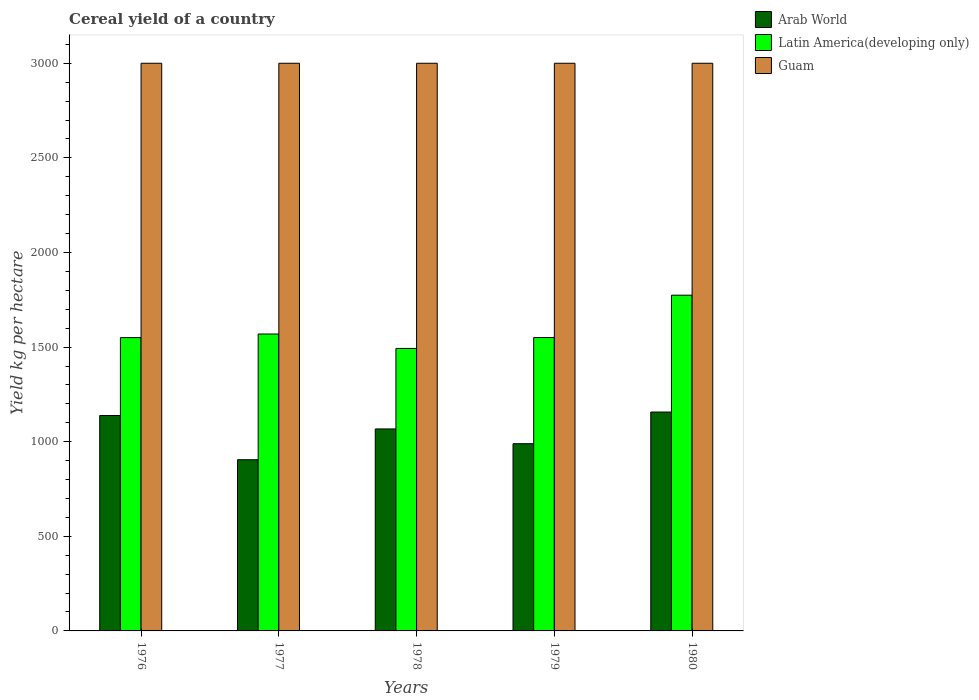How many groups of bars are there?
Your response must be concise. 5. Are the number of bars per tick equal to the number of legend labels?
Your answer should be very brief. Yes. Are the number of bars on each tick of the X-axis equal?
Your answer should be very brief. Yes. How many bars are there on the 4th tick from the left?
Offer a very short reply. 3. What is the label of the 1st group of bars from the left?
Keep it short and to the point. 1976. In how many cases, is the number of bars for a given year not equal to the number of legend labels?
Your answer should be compact. 0. What is the total cereal yield in Latin America(developing only) in 1980?
Provide a short and direct response. 1774.33. Across all years, what is the maximum total cereal yield in Guam?
Your answer should be very brief. 3000. Across all years, what is the minimum total cereal yield in Guam?
Provide a succinct answer. 3000. In which year was the total cereal yield in Guam maximum?
Make the answer very short. 1976. In which year was the total cereal yield in Guam minimum?
Make the answer very short. 1976. What is the total total cereal yield in Arab World in the graph?
Give a very brief answer. 5256.63. What is the difference between the total cereal yield in Latin America(developing only) in 1976 and that in 1978?
Your response must be concise. 57.32. What is the difference between the total cereal yield in Arab World in 1976 and the total cereal yield in Latin America(developing only) in 1979?
Offer a terse response. -412.12. What is the average total cereal yield in Arab World per year?
Your answer should be very brief. 1051.33. In the year 1980, what is the difference between the total cereal yield in Arab World and total cereal yield in Latin America(developing only)?
Offer a very short reply. -617.6. What is the ratio of the total cereal yield in Latin America(developing only) in 1977 to that in 1979?
Provide a short and direct response. 1.01. Is the total cereal yield in Arab World in 1977 less than that in 1980?
Make the answer very short. Yes. Is the difference between the total cereal yield in Arab World in 1976 and 1980 greater than the difference between the total cereal yield in Latin America(developing only) in 1976 and 1980?
Provide a short and direct response. Yes. What is the difference between the highest and the second highest total cereal yield in Arab World?
Provide a succinct answer. 18.37. What is the difference between the highest and the lowest total cereal yield in Guam?
Your response must be concise. 0. In how many years, is the total cereal yield in Latin America(developing only) greater than the average total cereal yield in Latin America(developing only) taken over all years?
Provide a short and direct response. 1. What does the 3rd bar from the left in 1978 represents?
Offer a terse response. Guam. What does the 2nd bar from the right in 1979 represents?
Your response must be concise. Latin America(developing only). Is it the case that in every year, the sum of the total cereal yield in Latin America(developing only) and total cereal yield in Guam is greater than the total cereal yield in Arab World?
Your response must be concise. Yes. Are the values on the major ticks of Y-axis written in scientific E-notation?
Make the answer very short. No. Does the graph contain grids?
Your answer should be compact. No. Where does the legend appear in the graph?
Make the answer very short. Top right. What is the title of the graph?
Keep it short and to the point. Cereal yield of a country. What is the label or title of the X-axis?
Ensure brevity in your answer.  Years. What is the label or title of the Y-axis?
Provide a short and direct response. Yield kg per hectare. What is the Yield kg per hectare in Arab World in 1976?
Offer a terse response. 1138.36. What is the Yield kg per hectare of Latin America(developing only) in 1976?
Keep it short and to the point. 1550.12. What is the Yield kg per hectare of Guam in 1976?
Your answer should be compact. 3000. What is the Yield kg per hectare in Arab World in 1977?
Ensure brevity in your answer.  904.76. What is the Yield kg per hectare in Latin America(developing only) in 1977?
Offer a very short reply. 1569.11. What is the Yield kg per hectare of Guam in 1977?
Your answer should be compact. 3000. What is the Yield kg per hectare in Arab World in 1978?
Ensure brevity in your answer.  1067.4. What is the Yield kg per hectare in Latin America(developing only) in 1978?
Your answer should be compact. 1492.8. What is the Yield kg per hectare of Guam in 1978?
Offer a terse response. 3000. What is the Yield kg per hectare in Arab World in 1979?
Offer a terse response. 989.38. What is the Yield kg per hectare in Latin America(developing only) in 1979?
Make the answer very short. 1550.48. What is the Yield kg per hectare in Guam in 1979?
Ensure brevity in your answer.  3000. What is the Yield kg per hectare of Arab World in 1980?
Keep it short and to the point. 1156.73. What is the Yield kg per hectare of Latin America(developing only) in 1980?
Ensure brevity in your answer.  1774.33. What is the Yield kg per hectare in Guam in 1980?
Offer a terse response. 3000. Across all years, what is the maximum Yield kg per hectare in Arab World?
Provide a succinct answer. 1156.73. Across all years, what is the maximum Yield kg per hectare in Latin America(developing only)?
Your answer should be compact. 1774.33. Across all years, what is the maximum Yield kg per hectare of Guam?
Offer a terse response. 3000. Across all years, what is the minimum Yield kg per hectare in Arab World?
Keep it short and to the point. 904.76. Across all years, what is the minimum Yield kg per hectare of Latin America(developing only)?
Offer a very short reply. 1492.8. Across all years, what is the minimum Yield kg per hectare of Guam?
Your answer should be compact. 3000. What is the total Yield kg per hectare of Arab World in the graph?
Ensure brevity in your answer.  5256.63. What is the total Yield kg per hectare in Latin America(developing only) in the graph?
Your response must be concise. 7936.85. What is the total Yield kg per hectare in Guam in the graph?
Keep it short and to the point. 1.50e+04. What is the difference between the Yield kg per hectare of Arab World in 1976 and that in 1977?
Make the answer very short. 233.6. What is the difference between the Yield kg per hectare of Latin America(developing only) in 1976 and that in 1977?
Give a very brief answer. -18.99. What is the difference between the Yield kg per hectare in Arab World in 1976 and that in 1978?
Offer a terse response. 70.96. What is the difference between the Yield kg per hectare of Latin America(developing only) in 1976 and that in 1978?
Provide a short and direct response. 57.32. What is the difference between the Yield kg per hectare in Arab World in 1976 and that in 1979?
Ensure brevity in your answer.  148.97. What is the difference between the Yield kg per hectare of Latin America(developing only) in 1976 and that in 1979?
Your answer should be very brief. -0.36. What is the difference between the Yield kg per hectare of Arab World in 1976 and that in 1980?
Keep it short and to the point. -18.37. What is the difference between the Yield kg per hectare of Latin America(developing only) in 1976 and that in 1980?
Keep it short and to the point. -224.21. What is the difference between the Yield kg per hectare of Guam in 1976 and that in 1980?
Ensure brevity in your answer.  0. What is the difference between the Yield kg per hectare in Arab World in 1977 and that in 1978?
Provide a short and direct response. -162.64. What is the difference between the Yield kg per hectare of Latin America(developing only) in 1977 and that in 1978?
Keep it short and to the point. 76.31. What is the difference between the Yield kg per hectare of Arab World in 1977 and that in 1979?
Make the answer very short. -84.63. What is the difference between the Yield kg per hectare in Latin America(developing only) in 1977 and that in 1979?
Your response must be concise. 18.63. What is the difference between the Yield kg per hectare of Guam in 1977 and that in 1979?
Your answer should be compact. 0. What is the difference between the Yield kg per hectare of Arab World in 1977 and that in 1980?
Offer a terse response. -251.97. What is the difference between the Yield kg per hectare of Latin America(developing only) in 1977 and that in 1980?
Provide a succinct answer. -205.22. What is the difference between the Yield kg per hectare in Guam in 1977 and that in 1980?
Ensure brevity in your answer.  0. What is the difference between the Yield kg per hectare of Arab World in 1978 and that in 1979?
Your answer should be very brief. 78.01. What is the difference between the Yield kg per hectare in Latin America(developing only) in 1978 and that in 1979?
Your response must be concise. -57.68. What is the difference between the Yield kg per hectare of Guam in 1978 and that in 1979?
Provide a short and direct response. 0. What is the difference between the Yield kg per hectare of Arab World in 1978 and that in 1980?
Offer a terse response. -89.33. What is the difference between the Yield kg per hectare in Latin America(developing only) in 1978 and that in 1980?
Your answer should be very brief. -281.53. What is the difference between the Yield kg per hectare in Guam in 1978 and that in 1980?
Provide a succinct answer. 0. What is the difference between the Yield kg per hectare of Arab World in 1979 and that in 1980?
Provide a short and direct response. -167.35. What is the difference between the Yield kg per hectare in Latin America(developing only) in 1979 and that in 1980?
Your response must be concise. -223.85. What is the difference between the Yield kg per hectare in Arab World in 1976 and the Yield kg per hectare in Latin America(developing only) in 1977?
Provide a short and direct response. -430.76. What is the difference between the Yield kg per hectare in Arab World in 1976 and the Yield kg per hectare in Guam in 1977?
Provide a short and direct response. -1861.64. What is the difference between the Yield kg per hectare in Latin America(developing only) in 1976 and the Yield kg per hectare in Guam in 1977?
Ensure brevity in your answer.  -1449.88. What is the difference between the Yield kg per hectare in Arab World in 1976 and the Yield kg per hectare in Latin America(developing only) in 1978?
Your answer should be compact. -354.44. What is the difference between the Yield kg per hectare of Arab World in 1976 and the Yield kg per hectare of Guam in 1978?
Keep it short and to the point. -1861.64. What is the difference between the Yield kg per hectare in Latin America(developing only) in 1976 and the Yield kg per hectare in Guam in 1978?
Your response must be concise. -1449.88. What is the difference between the Yield kg per hectare in Arab World in 1976 and the Yield kg per hectare in Latin America(developing only) in 1979?
Offer a very short reply. -412.12. What is the difference between the Yield kg per hectare of Arab World in 1976 and the Yield kg per hectare of Guam in 1979?
Ensure brevity in your answer.  -1861.64. What is the difference between the Yield kg per hectare of Latin America(developing only) in 1976 and the Yield kg per hectare of Guam in 1979?
Give a very brief answer. -1449.88. What is the difference between the Yield kg per hectare of Arab World in 1976 and the Yield kg per hectare of Latin America(developing only) in 1980?
Offer a very short reply. -635.97. What is the difference between the Yield kg per hectare of Arab World in 1976 and the Yield kg per hectare of Guam in 1980?
Ensure brevity in your answer.  -1861.64. What is the difference between the Yield kg per hectare in Latin America(developing only) in 1976 and the Yield kg per hectare in Guam in 1980?
Ensure brevity in your answer.  -1449.88. What is the difference between the Yield kg per hectare in Arab World in 1977 and the Yield kg per hectare in Latin America(developing only) in 1978?
Offer a very short reply. -588.04. What is the difference between the Yield kg per hectare in Arab World in 1977 and the Yield kg per hectare in Guam in 1978?
Provide a short and direct response. -2095.24. What is the difference between the Yield kg per hectare of Latin America(developing only) in 1977 and the Yield kg per hectare of Guam in 1978?
Give a very brief answer. -1430.89. What is the difference between the Yield kg per hectare in Arab World in 1977 and the Yield kg per hectare in Latin America(developing only) in 1979?
Ensure brevity in your answer.  -645.72. What is the difference between the Yield kg per hectare of Arab World in 1977 and the Yield kg per hectare of Guam in 1979?
Provide a short and direct response. -2095.24. What is the difference between the Yield kg per hectare in Latin America(developing only) in 1977 and the Yield kg per hectare in Guam in 1979?
Your answer should be very brief. -1430.89. What is the difference between the Yield kg per hectare in Arab World in 1977 and the Yield kg per hectare in Latin America(developing only) in 1980?
Offer a very short reply. -869.57. What is the difference between the Yield kg per hectare of Arab World in 1977 and the Yield kg per hectare of Guam in 1980?
Your answer should be compact. -2095.24. What is the difference between the Yield kg per hectare in Latin America(developing only) in 1977 and the Yield kg per hectare in Guam in 1980?
Give a very brief answer. -1430.89. What is the difference between the Yield kg per hectare of Arab World in 1978 and the Yield kg per hectare of Latin America(developing only) in 1979?
Offer a terse response. -483.08. What is the difference between the Yield kg per hectare of Arab World in 1978 and the Yield kg per hectare of Guam in 1979?
Offer a terse response. -1932.6. What is the difference between the Yield kg per hectare of Latin America(developing only) in 1978 and the Yield kg per hectare of Guam in 1979?
Provide a short and direct response. -1507.2. What is the difference between the Yield kg per hectare in Arab World in 1978 and the Yield kg per hectare in Latin America(developing only) in 1980?
Ensure brevity in your answer.  -706.93. What is the difference between the Yield kg per hectare of Arab World in 1978 and the Yield kg per hectare of Guam in 1980?
Ensure brevity in your answer.  -1932.6. What is the difference between the Yield kg per hectare in Latin America(developing only) in 1978 and the Yield kg per hectare in Guam in 1980?
Your response must be concise. -1507.2. What is the difference between the Yield kg per hectare in Arab World in 1979 and the Yield kg per hectare in Latin America(developing only) in 1980?
Your answer should be compact. -784.95. What is the difference between the Yield kg per hectare in Arab World in 1979 and the Yield kg per hectare in Guam in 1980?
Keep it short and to the point. -2010.62. What is the difference between the Yield kg per hectare in Latin America(developing only) in 1979 and the Yield kg per hectare in Guam in 1980?
Offer a terse response. -1449.52. What is the average Yield kg per hectare of Arab World per year?
Provide a succinct answer. 1051.33. What is the average Yield kg per hectare in Latin America(developing only) per year?
Keep it short and to the point. 1587.37. What is the average Yield kg per hectare of Guam per year?
Ensure brevity in your answer.  3000. In the year 1976, what is the difference between the Yield kg per hectare in Arab World and Yield kg per hectare in Latin America(developing only)?
Offer a very short reply. -411.76. In the year 1976, what is the difference between the Yield kg per hectare of Arab World and Yield kg per hectare of Guam?
Provide a succinct answer. -1861.64. In the year 1976, what is the difference between the Yield kg per hectare in Latin America(developing only) and Yield kg per hectare in Guam?
Your answer should be compact. -1449.88. In the year 1977, what is the difference between the Yield kg per hectare of Arab World and Yield kg per hectare of Latin America(developing only)?
Your answer should be compact. -664.36. In the year 1977, what is the difference between the Yield kg per hectare of Arab World and Yield kg per hectare of Guam?
Keep it short and to the point. -2095.24. In the year 1977, what is the difference between the Yield kg per hectare in Latin America(developing only) and Yield kg per hectare in Guam?
Ensure brevity in your answer.  -1430.89. In the year 1978, what is the difference between the Yield kg per hectare of Arab World and Yield kg per hectare of Latin America(developing only)?
Your response must be concise. -425.41. In the year 1978, what is the difference between the Yield kg per hectare of Arab World and Yield kg per hectare of Guam?
Offer a terse response. -1932.6. In the year 1978, what is the difference between the Yield kg per hectare of Latin America(developing only) and Yield kg per hectare of Guam?
Your response must be concise. -1507.2. In the year 1979, what is the difference between the Yield kg per hectare in Arab World and Yield kg per hectare in Latin America(developing only)?
Your answer should be compact. -561.1. In the year 1979, what is the difference between the Yield kg per hectare in Arab World and Yield kg per hectare in Guam?
Make the answer very short. -2010.62. In the year 1979, what is the difference between the Yield kg per hectare of Latin America(developing only) and Yield kg per hectare of Guam?
Provide a short and direct response. -1449.52. In the year 1980, what is the difference between the Yield kg per hectare in Arab World and Yield kg per hectare in Latin America(developing only)?
Offer a very short reply. -617.6. In the year 1980, what is the difference between the Yield kg per hectare in Arab World and Yield kg per hectare in Guam?
Provide a succinct answer. -1843.27. In the year 1980, what is the difference between the Yield kg per hectare in Latin America(developing only) and Yield kg per hectare in Guam?
Give a very brief answer. -1225.67. What is the ratio of the Yield kg per hectare in Arab World in 1976 to that in 1977?
Keep it short and to the point. 1.26. What is the ratio of the Yield kg per hectare in Latin America(developing only) in 1976 to that in 1977?
Ensure brevity in your answer.  0.99. What is the ratio of the Yield kg per hectare of Arab World in 1976 to that in 1978?
Your response must be concise. 1.07. What is the ratio of the Yield kg per hectare in Latin America(developing only) in 1976 to that in 1978?
Your answer should be compact. 1.04. What is the ratio of the Yield kg per hectare of Arab World in 1976 to that in 1979?
Your response must be concise. 1.15. What is the ratio of the Yield kg per hectare in Guam in 1976 to that in 1979?
Give a very brief answer. 1. What is the ratio of the Yield kg per hectare in Arab World in 1976 to that in 1980?
Provide a short and direct response. 0.98. What is the ratio of the Yield kg per hectare of Latin America(developing only) in 1976 to that in 1980?
Your answer should be compact. 0.87. What is the ratio of the Yield kg per hectare in Guam in 1976 to that in 1980?
Offer a very short reply. 1. What is the ratio of the Yield kg per hectare of Arab World in 1977 to that in 1978?
Provide a succinct answer. 0.85. What is the ratio of the Yield kg per hectare of Latin America(developing only) in 1977 to that in 1978?
Your response must be concise. 1.05. What is the ratio of the Yield kg per hectare in Guam in 1977 to that in 1978?
Ensure brevity in your answer.  1. What is the ratio of the Yield kg per hectare of Arab World in 1977 to that in 1979?
Offer a terse response. 0.91. What is the ratio of the Yield kg per hectare of Guam in 1977 to that in 1979?
Give a very brief answer. 1. What is the ratio of the Yield kg per hectare of Arab World in 1977 to that in 1980?
Offer a terse response. 0.78. What is the ratio of the Yield kg per hectare in Latin America(developing only) in 1977 to that in 1980?
Offer a terse response. 0.88. What is the ratio of the Yield kg per hectare of Arab World in 1978 to that in 1979?
Your response must be concise. 1.08. What is the ratio of the Yield kg per hectare in Latin America(developing only) in 1978 to that in 1979?
Give a very brief answer. 0.96. What is the ratio of the Yield kg per hectare of Arab World in 1978 to that in 1980?
Keep it short and to the point. 0.92. What is the ratio of the Yield kg per hectare in Latin America(developing only) in 1978 to that in 1980?
Keep it short and to the point. 0.84. What is the ratio of the Yield kg per hectare of Arab World in 1979 to that in 1980?
Your answer should be very brief. 0.86. What is the ratio of the Yield kg per hectare of Latin America(developing only) in 1979 to that in 1980?
Offer a terse response. 0.87. What is the ratio of the Yield kg per hectare of Guam in 1979 to that in 1980?
Provide a succinct answer. 1. What is the difference between the highest and the second highest Yield kg per hectare in Arab World?
Make the answer very short. 18.37. What is the difference between the highest and the second highest Yield kg per hectare in Latin America(developing only)?
Offer a very short reply. 205.22. What is the difference between the highest and the lowest Yield kg per hectare of Arab World?
Provide a succinct answer. 251.97. What is the difference between the highest and the lowest Yield kg per hectare in Latin America(developing only)?
Offer a terse response. 281.53. 